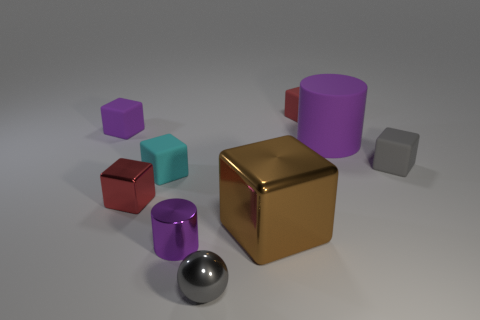Subtract all purple cylinders. How many were subtracted if there are1purple cylinders left? 1 Subtract all blocks. How many objects are left? 3 Subtract 1 balls. How many balls are left? 0 Subtract all yellow cylinders. Subtract all green balls. How many cylinders are left? 2 Subtract all cyan cylinders. How many gray blocks are left? 1 Subtract all big purple rubber cylinders. Subtract all small cyan objects. How many objects are left? 7 Add 5 tiny purple matte objects. How many tiny purple matte objects are left? 6 Add 7 green rubber cylinders. How many green rubber cylinders exist? 7 Subtract all purple cubes. How many cubes are left? 5 Subtract all purple matte blocks. How many blocks are left? 5 